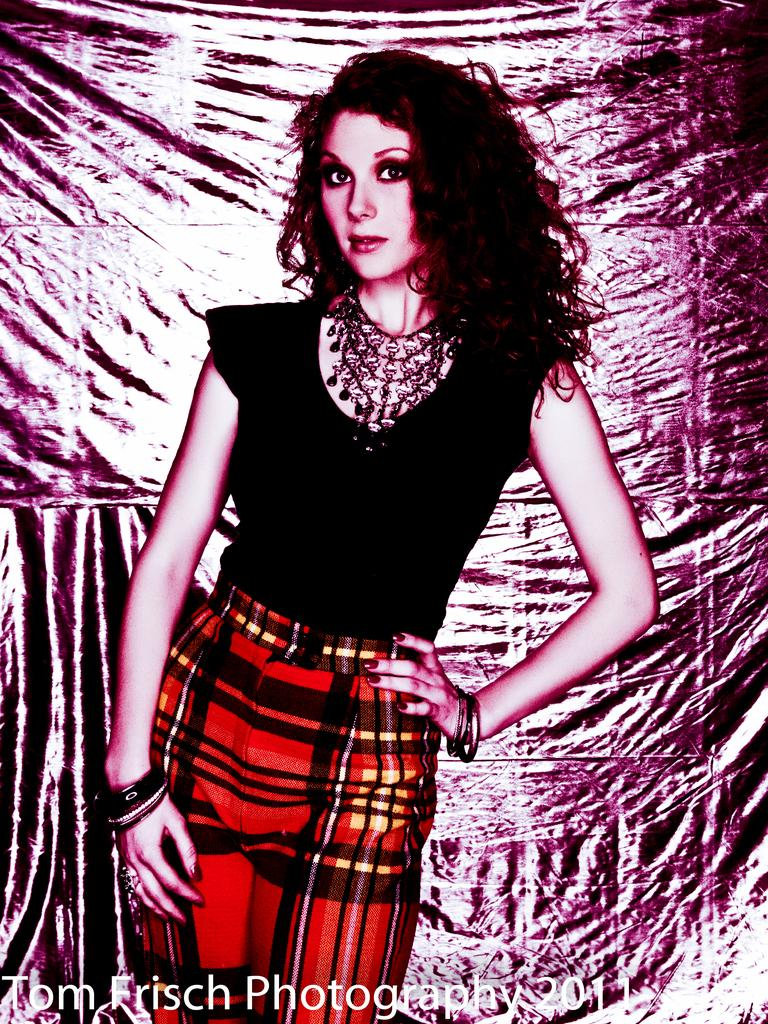What is the main subject of the image? There is a person in the image. What is the person wearing? The person is wearing a red and black colored dress. What is the person's posture in the image? The person is standing. What can be seen at the bottom of the image? There is text written at the bottom of the image. How many friends does the person in the image have? The image does not provide information about the person's friends, so it cannot be determined from the image. 